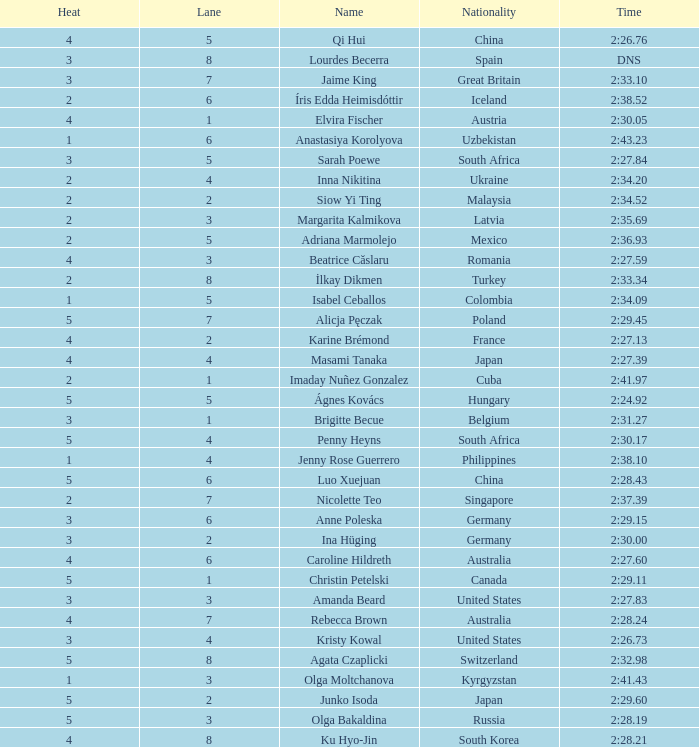What lane did inna nikitina have? 4.0. 